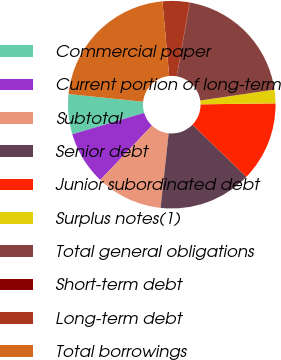Convert chart. <chart><loc_0><loc_0><loc_500><loc_500><pie_chart><fcel>Commercial paper<fcel>Current portion of long-term<fcel>Subtotal<fcel>Senior debt<fcel>Junior subordinated debt<fcel>Surplus notes(1)<fcel>Total general obligations<fcel>Short-term debt<fcel>Long-term debt<fcel>Total borrowings<nl><fcel>6.24%<fcel>8.31%<fcel>10.37%<fcel>14.49%<fcel>12.43%<fcel>2.12%<fcel>19.87%<fcel>0.06%<fcel>4.18%<fcel>21.93%<nl></chart> 